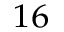<formula> <loc_0><loc_0><loc_500><loc_500>^ { 1 6 }</formula> 